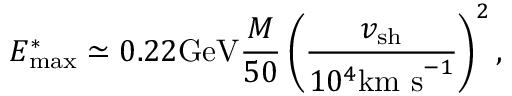Convert formula to latex. <formula><loc_0><loc_0><loc_500><loc_500>E _ { \max } ^ { * } \simeq 0 . 2 2 G e V \frac { M } { 5 0 } \left ( \frac { v _ { s h } } { 1 0 ^ { 4 } k m s ^ { - 1 } } \right ) ^ { 2 } ,</formula> 